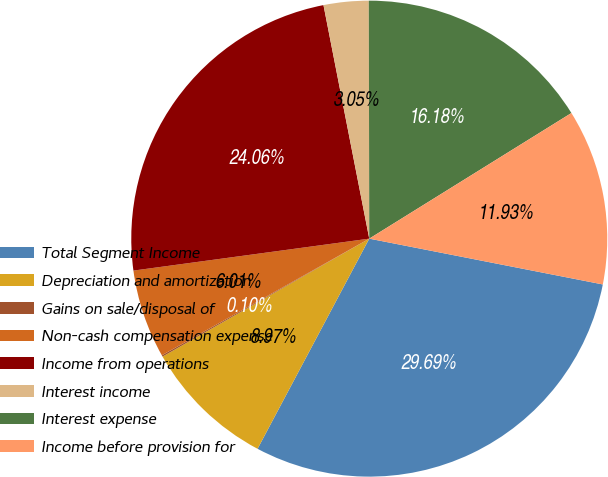<chart> <loc_0><loc_0><loc_500><loc_500><pie_chart><fcel>Total Segment Income<fcel>Depreciation and amortization<fcel>Gains on sale/disposal of<fcel>Non-cash compensation expense<fcel>Income from operations<fcel>Interest income<fcel>Interest expense<fcel>Income before provision for<nl><fcel>29.69%<fcel>8.97%<fcel>0.1%<fcel>6.01%<fcel>24.06%<fcel>3.05%<fcel>16.18%<fcel>11.93%<nl></chart> 